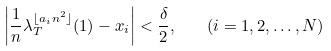<formula> <loc_0><loc_0><loc_500><loc_500>\left | \frac { 1 } { n } \lambda _ { T } ^ { \lfloor a _ { i } n ^ { 2 } \rfloor } ( 1 ) - x _ { i } \right | < \frac { \delta } { 2 } , \quad ( i = 1 , 2 , \dots , N )</formula> 